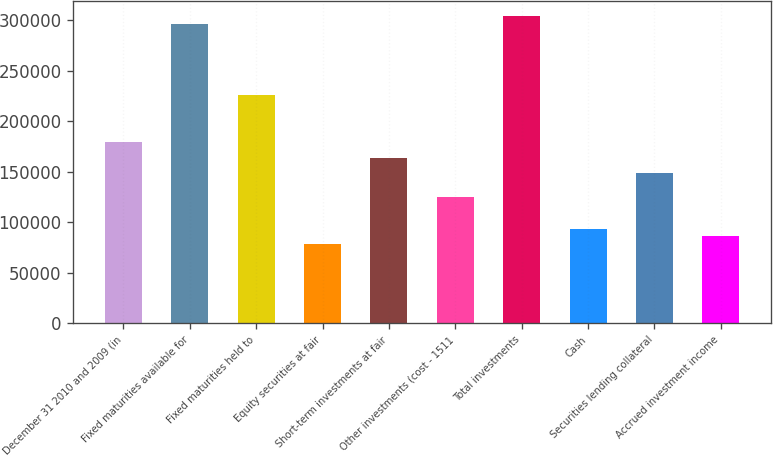Convert chart to OTSL. <chart><loc_0><loc_0><loc_500><loc_500><bar_chart><fcel>December 31 2010 and 2009 (in<fcel>Fixed maturities available for<fcel>Fixed maturities held to<fcel>Equity securities at fair<fcel>Short-term investments at fair<fcel>Other investments (cost - 1511<fcel>Total investments<fcel>Cash<fcel>Securities lending collateral<fcel>Accrued investment income<nl><fcel>179351<fcel>296318<fcel>226138<fcel>77980<fcel>163756<fcel>124767<fcel>304116<fcel>93575.6<fcel>148160<fcel>85777.8<nl></chart> 